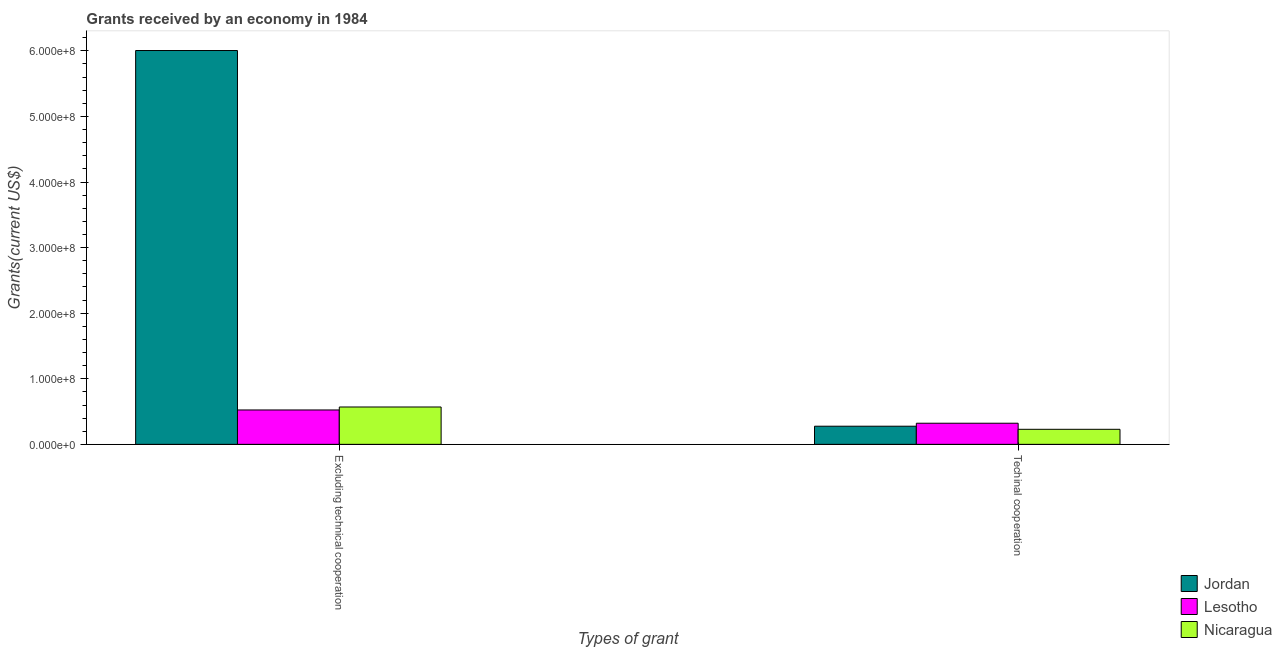How many groups of bars are there?
Offer a terse response. 2. Are the number of bars per tick equal to the number of legend labels?
Offer a very short reply. Yes. What is the label of the 1st group of bars from the left?
Your answer should be very brief. Excluding technical cooperation. What is the amount of grants received(including technical cooperation) in Nicaragua?
Provide a succinct answer. 2.29e+07. Across all countries, what is the maximum amount of grants received(including technical cooperation)?
Provide a succinct answer. 3.22e+07. Across all countries, what is the minimum amount of grants received(including technical cooperation)?
Your answer should be compact. 2.29e+07. In which country was the amount of grants received(including technical cooperation) maximum?
Make the answer very short. Lesotho. In which country was the amount of grants received(excluding technical cooperation) minimum?
Your answer should be very brief. Lesotho. What is the total amount of grants received(excluding technical cooperation) in the graph?
Your answer should be very brief. 7.10e+08. What is the difference between the amount of grants received(including technical cooperation) in Nicaragua and that in Jordan?
Provide a succinct answer. -4.74e+06. What is the difference between the amount of grants received(excluding technical cooperation) in Lesotho and the amount of grants received(including technical cooperation) in Jordan?
Make the answer very short. 2.48e+07. What is the average amount of grants received(excluding technical cooperation) per country?
Your answer should be compact. 2.37e+08. What is the difference between the amount of grants received(including technical cooperation) and amount of grants received(excluding technical cooperation) in Nicaragua?
Provide a short and direct response. -3.40e+07. In how many countries, is the amount of grants received(including technical cooperation) greater than 540000000 US$?
Keep it short and to the point. 0. What is the ratio of the amount of grants received(including technical cooperation) in Jordan to that in Nicaragua?
Offer a terse response. 1.21. Is the amount of grants received(including technical cooperation) in Nicaragua less than that in Jordan?
Provide a succinct answer. Yes. In how many countries, is the amount of grants received(excluding technical cooperation) greater than the average amount of grants received(excluding technical cooperation) taken over all countries?
Make the answer very short. 1. What does the 2nd bar from the left in Excluding technical cooperation represents?
Your answer should be very brief. Lesotho. What does the 2nd bar from the right in Excluding technical cooperation represents?
Your answer should be very brief. Lesotho. What is the difference between two consecutive major ticks on the Y-axis?
Provide a succinct answer. 1.00e+08. Are the values on the major ticks of Y-axis written in scientific E-notation?
Your response must be concise. Yes. Does the graph contain any zero values?
Your answer should be very brief. No. Where does the legend appear in the graph?
Keep it short and to the point. Bottom right. How many legend labels are there?
Your response must be concise. 3. What is the title of the graph?
Your answer should be compact. Grants received by an economy in 1984. What is the label or title of the X-axis?
Offer a terse response. Types of grant. What is the label or title of the Y-axis?
Offer a terse response. Grants(current US$). What is the Grants(current US$) in Jordan in Excluding technical cooperation?
Your answer should be very brief. 6.00e+08. What is the Grants(current US$) in Lesotho in Excluding technical cooperation?
Offer a very short reply. 5.24e+07. What is the Grants(current US$) of Nicaragua in Excluding technical cooperation?
Provide a succinct answer. 5.70e+07. What is the Grants(current US$) of Jordan in Techinal cooperation?
Offer a terse response. 2.77e+07. What is the Grants(current US$) of Lesotho in Techinal cooperation?
Provide a short and direct response. 3.22e+07. What is the Grants(current US$) in Nicaragua in Techinal cooperation?
Your answer should be compact. 2.29e+07. Across all Types of grant, what is the maximum Grants(current US$) in Jordan?
Give a very brief answer. 6.00e+08. Across all Types of grant, what is the maximum Grants(current US$) in Lesotho?
Make the answer very short. 5.24e+07. Across all Types of grant, what is the maximum Grants(current US$) in Nicaragua?
Your answer should be very brief. 5.70e+07. Across all Types of grant, what is the minimum Grants(current US$) of Jordan?
Provide a short and direct response. 2.77e+07. Across all Types of grant, what is the minimum Grants(current US$) of Lesotho?
Give a very brief answer. 3.22e+07. Across all Types of grant, what is the minimum Grants(current US$) of Nicaragua?
Your answer should be compact. 2.29e+07. What is the total Grants(current US$) in Jordan in the graph?
Keep it short and to the point. 6.28e+08. What is the total Grants(current US$) in Lesotho in the graph?
Ensure brevity in your answer.  8.47e+07. What is the total Grants(current US$) of Nicaragua in the graph?
Keep it short and to the point. 7.99e+07. What is the difference between the Grants(current US$) of Jordan in Excluding technical cooperation and that in Techinal cooperation?
Your response must be concise. 5.73e+08. What is the difference between the Grants(current US$) in Lesotho in Excluding technical cooperation and that in Techinal cooperation?
Give a very brief answer. 2.02e+07. What is the difference between the Grants(current US$) in Nicaragua in Excluding technical cooperation and that in Techinal cooperation?
Your response must be concise. 3.40e+07. What is the difference between the Grants(current US$) of Jordan in Excluding technical cooperation and the Grants(current US$) of Lesotho in Techinal cooperation?
Your response must be concise. 5.68e+08. What is the difference between the Grants(current US$) in Jordan in Excluding technical cooperation and the Grants(current US$) in Nicaragua in Techinal cooperation?
Provide a succinct answer. 5.78e+08. What is the difference between the Grants(current US$) in Lesotho in Excluding technical cooperation and the Grants(current US$) in Nicaragua in Techinal cooperation?
Your response must be concise. 2.95e+07. What is the average Grants(current US$) of Jordan per Types of grant?
Ensure brevity in your answer.  3.14e+08. What is the average Grants(current US$) in Lesotho per Types of grant?
Provide a succinct answer. 4.23e+07. What is the average Grants(current US$) of Nicaragua per Types of grant?
Make the answer very short. 4.00e+07. What is the difference between the Grants(current US$) in Jordan and Grants(current US$) in Lesotho in Excluding technical cooperation?
Keep it short and to the point. 5.48e+08. What is the difference between the Grants(current US$) in Jordan and Grants(current US$) in Nicaragua in Excluding technical cooperation?
Offer a terse response. 5.44e+08. What is the difference between the Grants(current US$) in Lesotho and Grants(current US$) in Nicaragua in Excluding technical cooperation?
Your response must be concise. -4.53e+06. What is the difference between the Grants(current US$) of Jordan and Grants(current US$) of Lesotho in Techinal cooperation?
Give a very brief answer. -4.53e+06. What is the difference between the Grants(current US$) of Jordan and Grants(current US$) of Nicaragua in Techinal cooperation?
Give a very brief answer. 4.74e+06. What is the difference between the Grants(current US$) in Lesotho and Grants(current US$) in Nicaragua in Techinal cooperation?
Keep it short and to the point. 9.27e+06. What is the ratio of the Grants(current US$) in Jordan in Excluding technical cooperation to that in Techinal cooperation?
Your answer should be very brief. 21.69. What is the ratio of the Grants(current US$) of Lesotho in Excluding technical cooperation to that in Techinal cooperation?
Offer a terse response. 1.63. What is the ratio of the Grants(current US$) in Nicaragua in Excluding technical cooperation to that in Techinal cooperation?
Offer a very short reply. 2.48. What is the difference between the highest and the second highest Grants(current US$) in Jordan?
Provide a short and direct response. 5.73e+08. What is the difference between the highest and the second highest Grants(current US$) in Lesotho?
Offer a terse response. 2.02e+07. What is the difference between the highest and the second highest Grants(current US$) of Nicaragua?
Keep it short and to the point. 3.40e+07. What is the difference between the highest and the lowest Grants(current US$) in Jordan?
Make the answer very short. 5.73e+08. What is the difference between the highest and the lowest Grants(current US$) of Lesotho?
Your answer should be very brief. 2.02e+07. What is the difference between the highest and the lowest Grants(current US$) of Nicaragua?
Provide a short and direct response. 3.40e+07. 